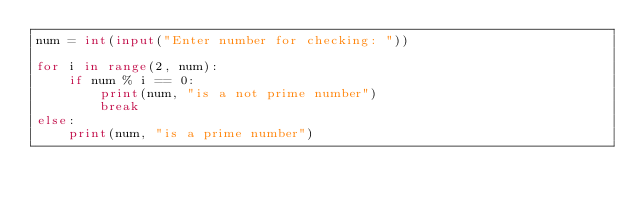Convert code to text. <code><loc_0><loc_0><loc_500><loc_500><_Python_>num = int(input("Enter number for checking: "))

for i in range(2, num):
    if num % i == 0:
        print(num, "is a not prime number")
        break
else:
    print(num, "is a prime number")

</code> 